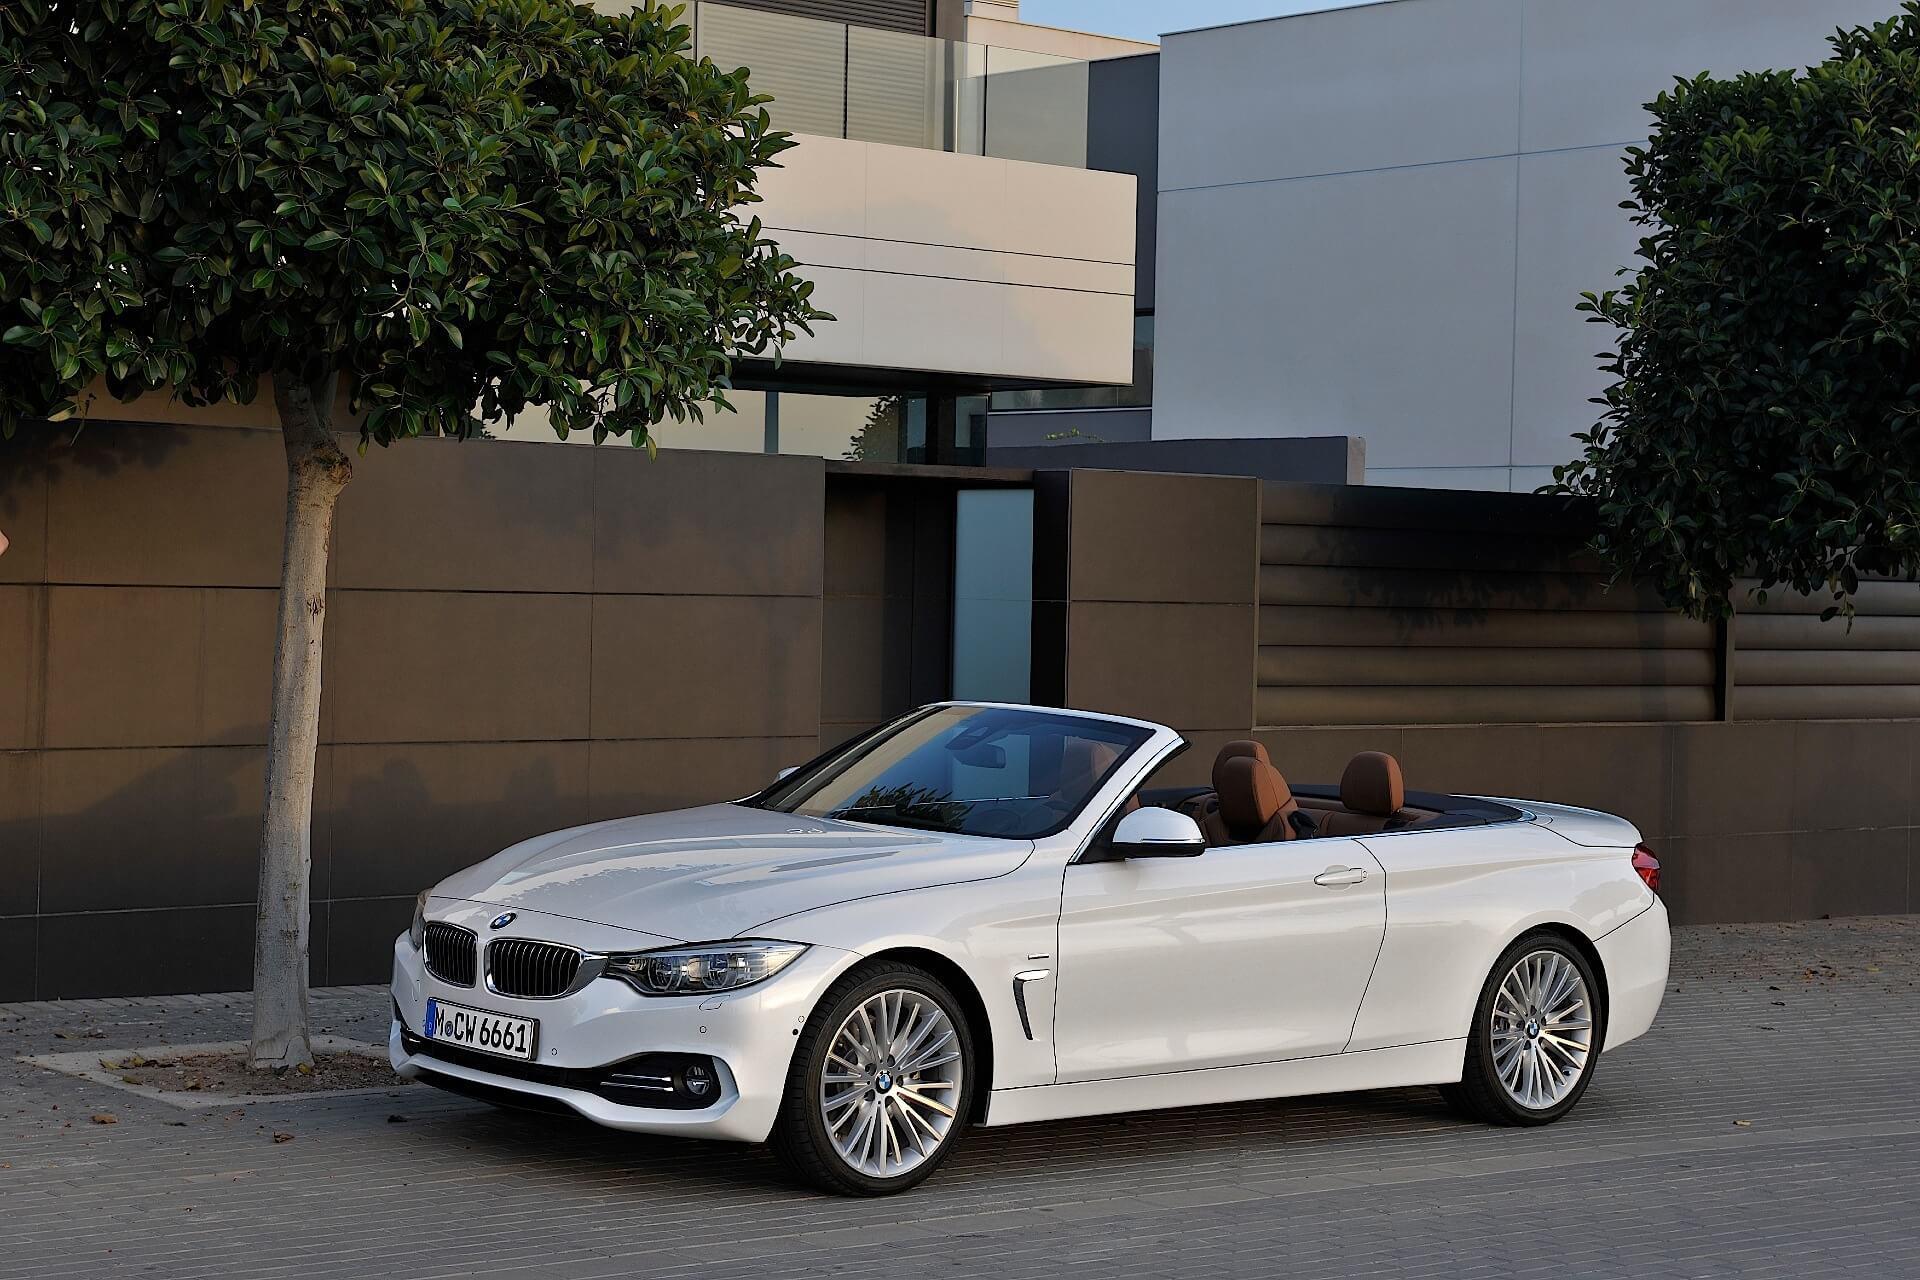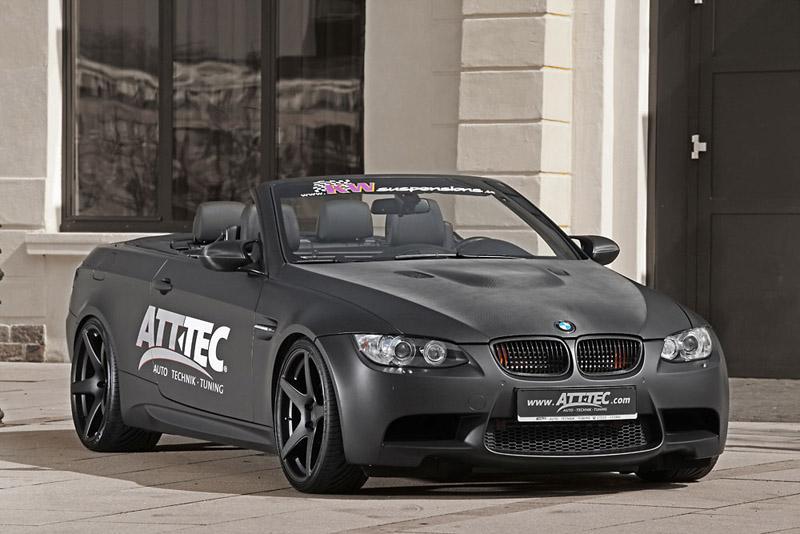The first image is the image on the left, the second image is the image on the right. Analyze the images presented: Is the assertion "Each image contains one topless convertible displayed at an angle, and the cars on the left and right are back-to-back, facing outward." valid? Answer yes or no. Yes. The first image is the image on the left, the second image is the image on the right. For the images shown, is this caption "In each image there is a convertible with its top down without any people present, but the cars are facing the opposite direction." true? Answer yes or no. Yes. 